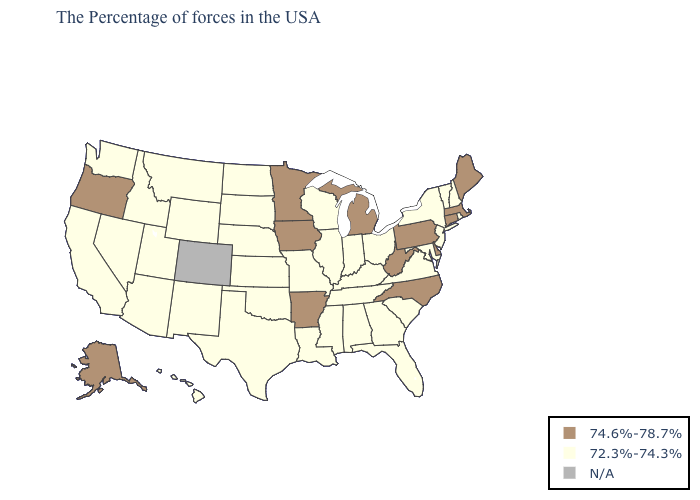Name the states that have a value in the range 72.3%-74.3%?
Be succinct. Rhode Island, New Hampshire, Vermont, New York, New Jersey, Maryland, Virginia, South Carolina, Ohio, Florida, Georgia, Kentucky, Indiana, Alabama, Tennessee, Wisconsin, Illinois, Mississippi, Louisiana, Missouri, Kansas, Nebraska, Oklahoma, Texas, South Dakota, North Dakota, Wyoming, New Mexico, Utah, Montana, Arizona, Idaho, Nevada, California, Washington, Hawaii. Among the states that border Arkansas , which have the lowest value?
Be succinct. Tennessee, Mississippi, Louisiana, Missouri, Oklahoma, Texas. Which states have the highest value in the USA?
Write a very short answer. Maine, Massachusetts, Connecticut, Delaware, Pennsylvania, North Carolina, West Virginia, Michigan, Arkansas, Minnesota, Iowa, Oregon, Alaska. Does the map have missing data?
Quick response, please. Yes. Name the states that have a value in the range N/A?
Write a very short answer. Colorado. Among the states that border Kansas , which have the highest value?
Be succinct. Missouri, Nebraska, Oklahoma. What is the value of Kentucky?
Answer briefly. 72.3%-74.3%. Does Florida have the lowest value in the USA?
Short answer required. Yes. Among the states that border Maryland , which have the lowest value?
Write a very short answer. Virginia. Which states have the highest value in the USA?
Quick response, please. Maine, Massachusetts, Connecticut, Delaware, Pennsylvania, North Carolina, West Virginia, Michigan, Arkansas, Minnesota, Iowa, Oregon, Alaska. Name the states that have a value in the range 72.3%-74.3%?
Concise answer only. Rhode Island, New Hampshire, Vermont, New York, New Jersey, Maryland, Virginia, South Carolina, Ohio, Florida, Georgia, Kentucky, Indiana, Alabama, Tennessee, Wisconsin, Illinois, Mississippi, Louisiana, Missouri, Kansas, Nebraska, Oklahoma, Texas, South Dakota, North Dakota, Wyoming, New Mexico, Utah, Montana, Arizona, Idaho, Nevada, California, Washington, Hawaii. Does the first symbol in the legend represent the smallest category?
Give a very brief answer. No. 